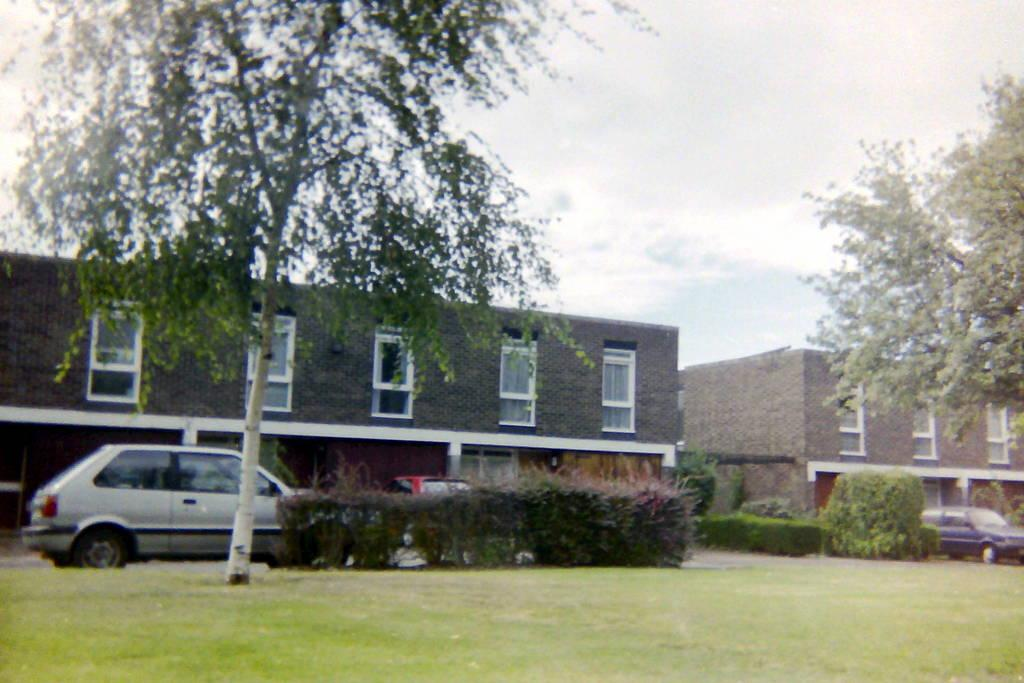What is happening on the road in the image? There are vehicles on the road in the image. What type of vegetation can be seen on the grassland in the image? There are plants and trees on the grassland in the image. What can be seen in the background of the image? There are buildings in the background of the image. What is visible at the top of the image? The sky is visible at the top of the image. Can you tell me the name of the river that flows through the image? There is no river present in the image; it features a road with vehicles, grassland with plants and trees, buildings in the background, and a visible sky. 